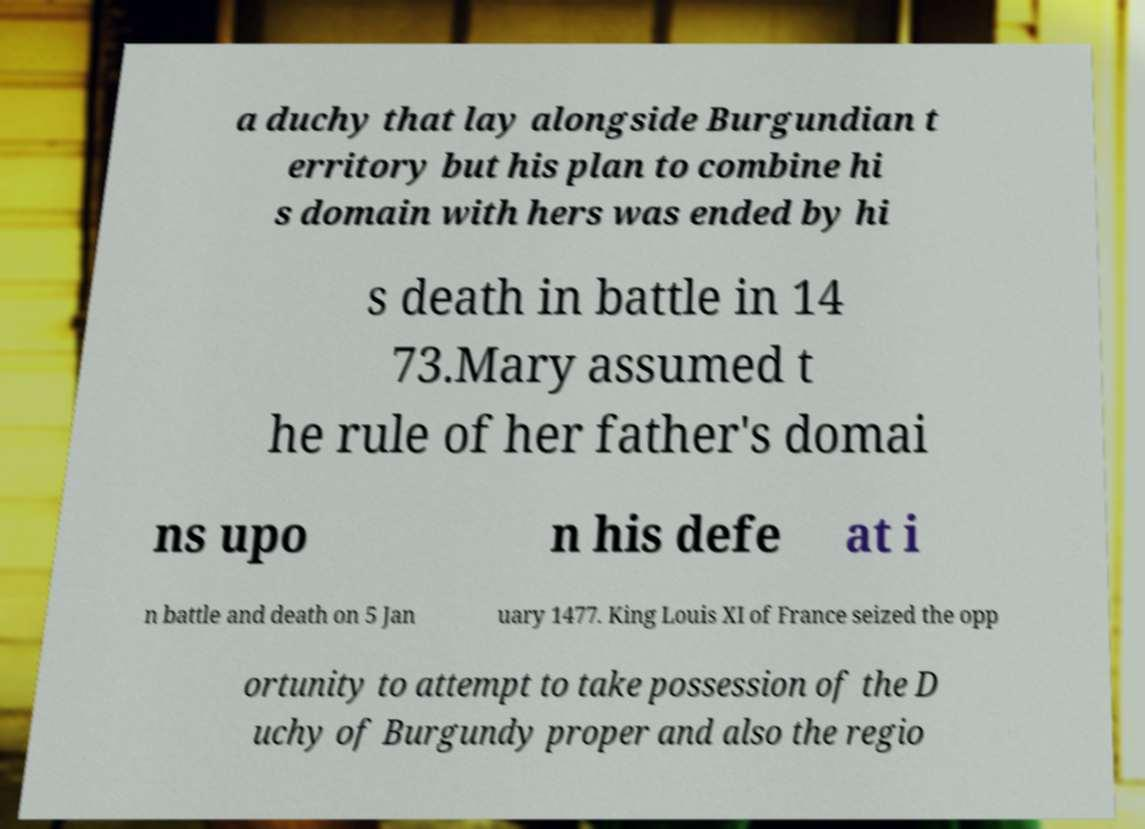Could you assist in decoding the text presented in this image and type it out clearly? a duchy that lay alongside Burgundian t erritory but his plan to combine hi s domain with hers was ended by hi s death in battle in 14 73.Mary assumed t he rule of her father's domai ns upo n his defe at i n battle and death on 5 Jan uary 1477. King Louis XI of France seized the opp ortunity to attempt to take possession of the D uchy of Burgundy proper and also the regio 